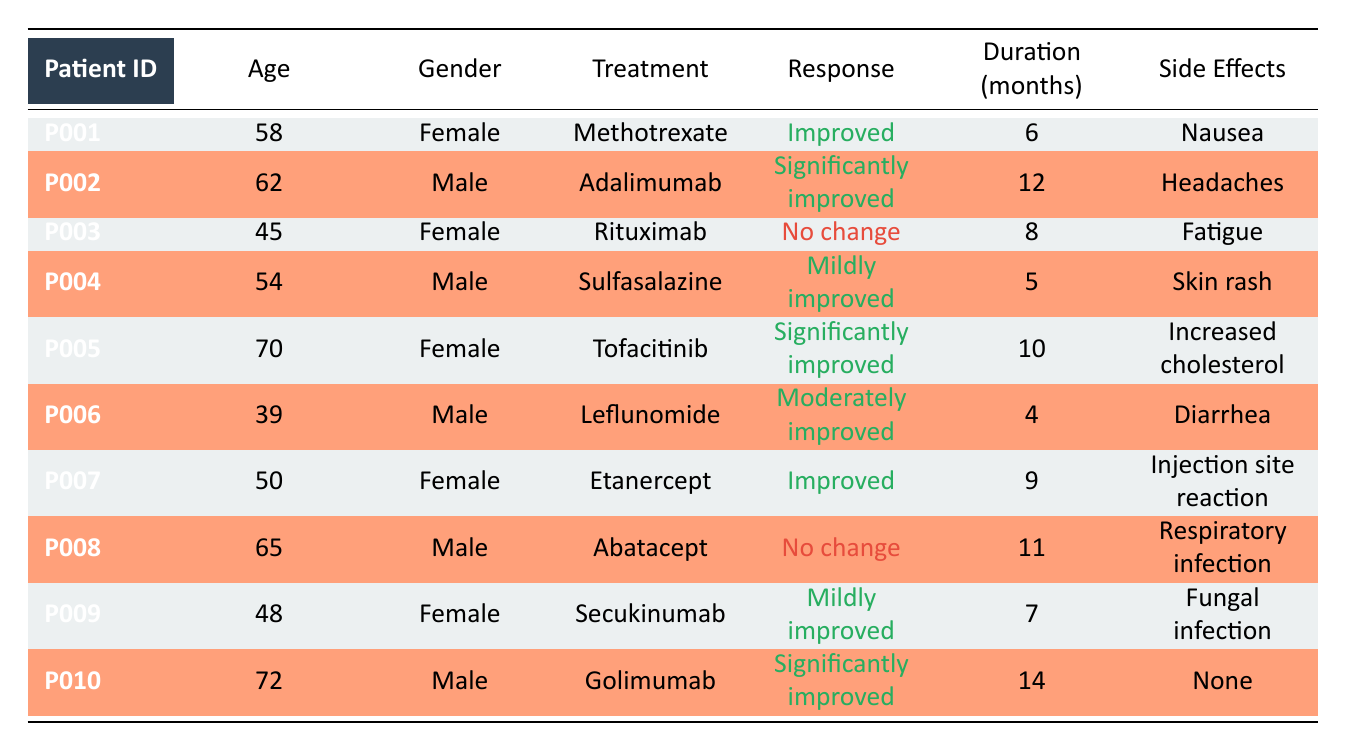What is the response of patient P005 to Tofacitinib? In the table, the response for patient P005, who is treated with Tofacitinib, is listed as "Significantly improved".
Answer: Significantly improved How many patients reported no change in response? By examining the response column for each patient, we find that both P003 (Rituximab) and P008 (Abatacept) reported "No change". Therefore, there are 2 patients.
Answer: 2 What is the average age of patients who experienced significantly improved responses? The patients who reported "Significantly improved" responses are P002 (62), P005 (70), and P010 (72). To calculate the average: (62 + 70 + 72) / 3 = 204 / 3 = 68.
Answer: 68 Is there any patient who experienced "Mildly improved" response and had experiences of side effects? Patient P004 (Sulfasalazine) had a "Mildly improved" response and reported a skin rash as a side effect. Therefore, the statement is true.
Answer: Yes What is the difference in treatment duration between patient P005 and P007? Patient P005 underwent treatment for 10 months (Tofacitinib), while P007 was treated for 9 months (Etanercept). The difference in duration is 10 - 9 = 1 month.
Answer: 1 month How many male patients reported improved responses? The male patients who reported improved responses are P002 (Adalimumab), P004 (Sulfasalazine), and P010 (Golimumab). This totals 3 male patients with improved responses.
Answer: 3 Which treatment had the longest reported duration among patients with improved responses? The treatments with improved responses include Methotrexate (6 months), Adalimumab (12 months), Sulfasalazine (5 months), Tofacitinib (10 months), Leflunomide (4 months), Etanercept (9 months), and Golimumab (14 months). The longest duration is 14 months from Golimumab by patient P010.
Answer: Golimumab What side effect did patient P001 experience? The side effects for patient P001, who was treated with Methotrexate, are listed as "Nausea" in the table.
Answer: Nausea What is the total number of patients included in the dataset? Counting all the patients listed in the table, we find there are 10 patients from P001 to P010.
Answer: 10 